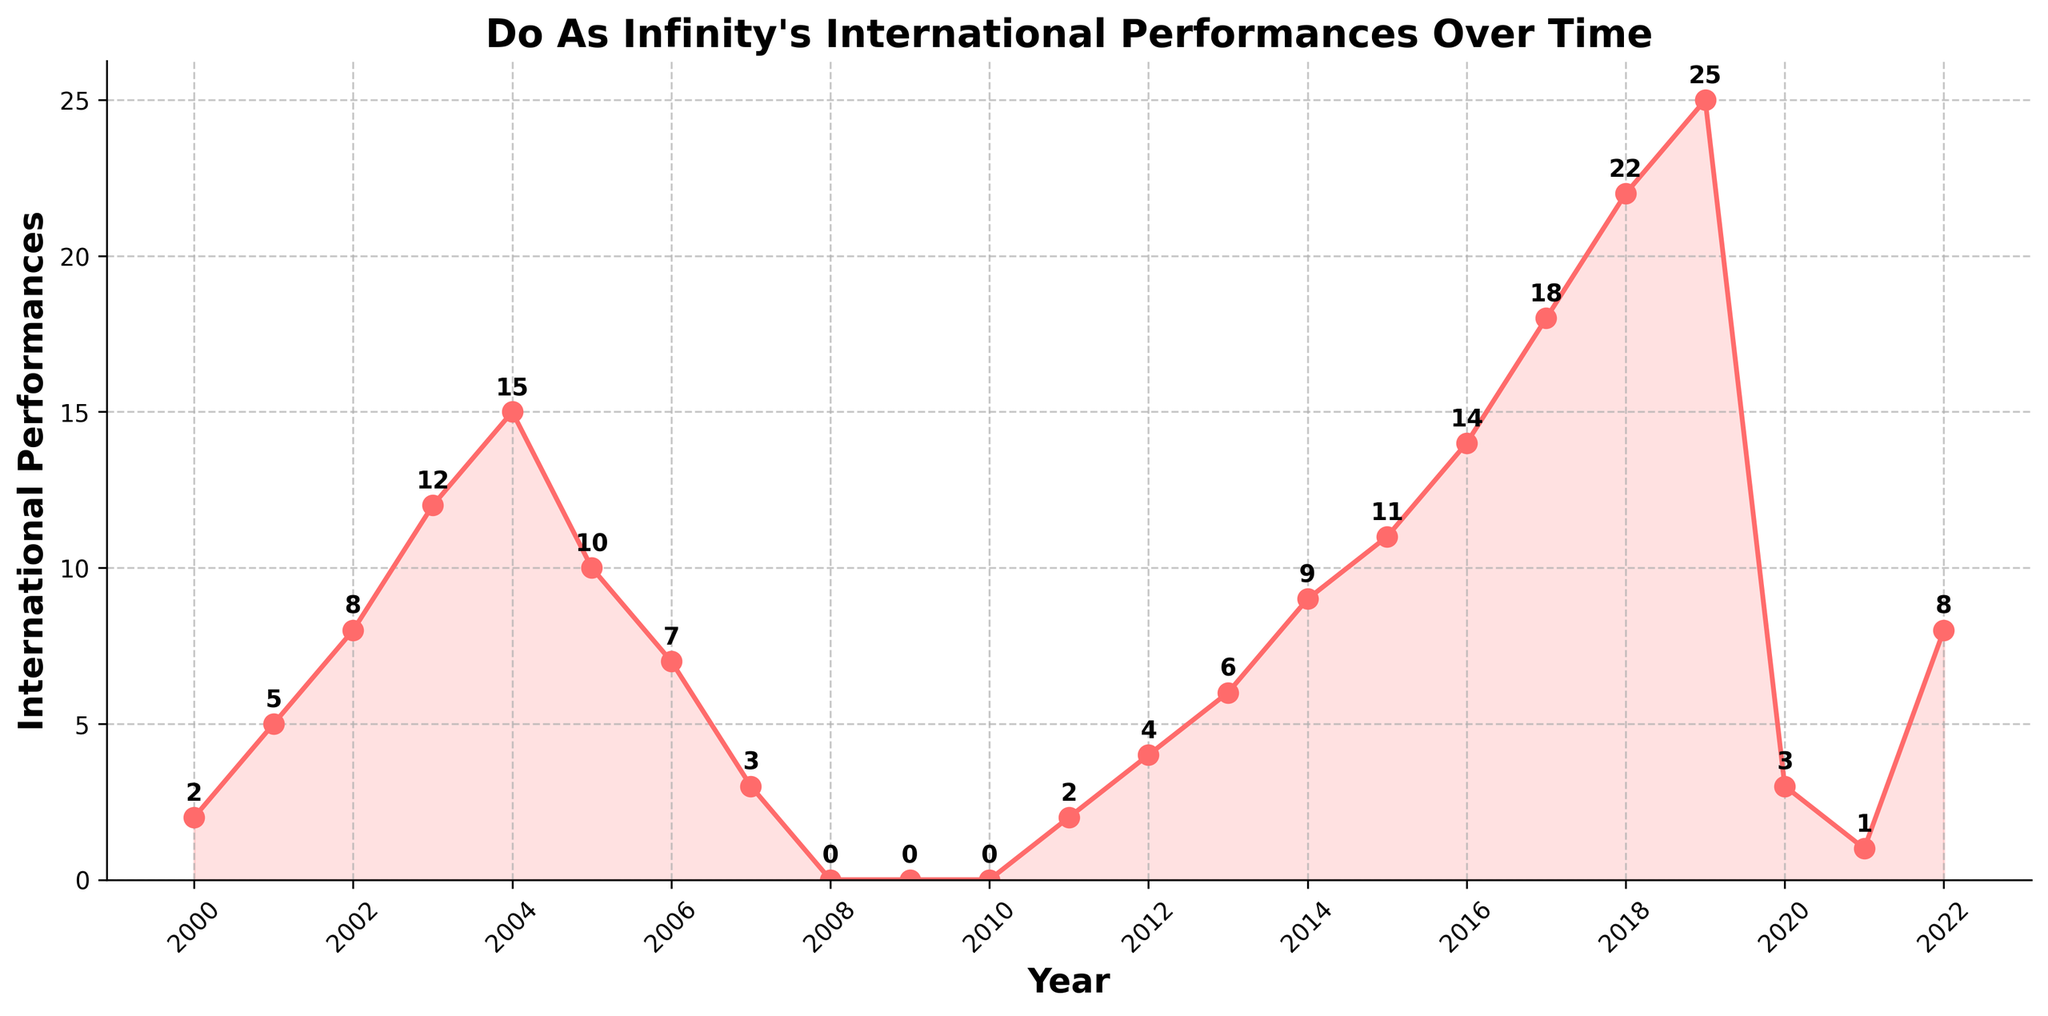Which year had the highest number of international performances? By looking at the plot, locate the highest point on the line chart, which represents the year with the most international performances.
Answer: 2019 Between 2008 and 2010, how many years had zero international performances? Examine the years 2008, 2009, and 2010 on the plot to see if the line touches zero for each of these years.
Answer: 3 What is the average number of international performances from 2017 to 2019? Calculate the sum of international performances from 2017 (18), 2018 (22), and 2019 (25), which is 65. Then, divide by the number of years (3). 65/3 = 21.67
Answer: 21.67 In which year did international performances sharply decline from the previous year? Identify the years where the slope of the line sharply goes down. For instance, between 2019 and 2020, there is a drastic drop.
Answer: 2020 What is the difference in the number of international performances between 2005 and 2007? Look at the values for 2005 (10 performances) and 2007 (3 performances). Subtract the smaller number from the larger one: 10 - 3 = 7.
Answer: 7 Which year had the fewest international performances after 2010? Check the years after 2010 and find the year with the lowest number of performances. The plot shows the lowest point is in 2021 (1 performance).
Answer: 2021 How many more performances were there in 2016 compared to 2006? Find the number of performances in 2016 (14) and 2006 (7), then subtract the smaller number from the larger one: 14 - 7 = 7.
Answer: 7 What is the median number of international performances for the years 2011 to 2022 inclusive? List the number of performances for the years 2011 (2), 2012 (4), 2013 (6), 2014 (9), 2015 (11), 2016 (14), 2017 (18), 2018 (22), 2019 (25), 2020 (3), 2021 (1), and 2022 (8). Order them: [1, 2, 3, 4, 6, 8, 9, 11, 14, 18, 22, 25]. The median value for an even number of data points (12) is the average of the 6th and 7th values: (8 + 9) / 2 = 8.5.
Answer: 8.5 